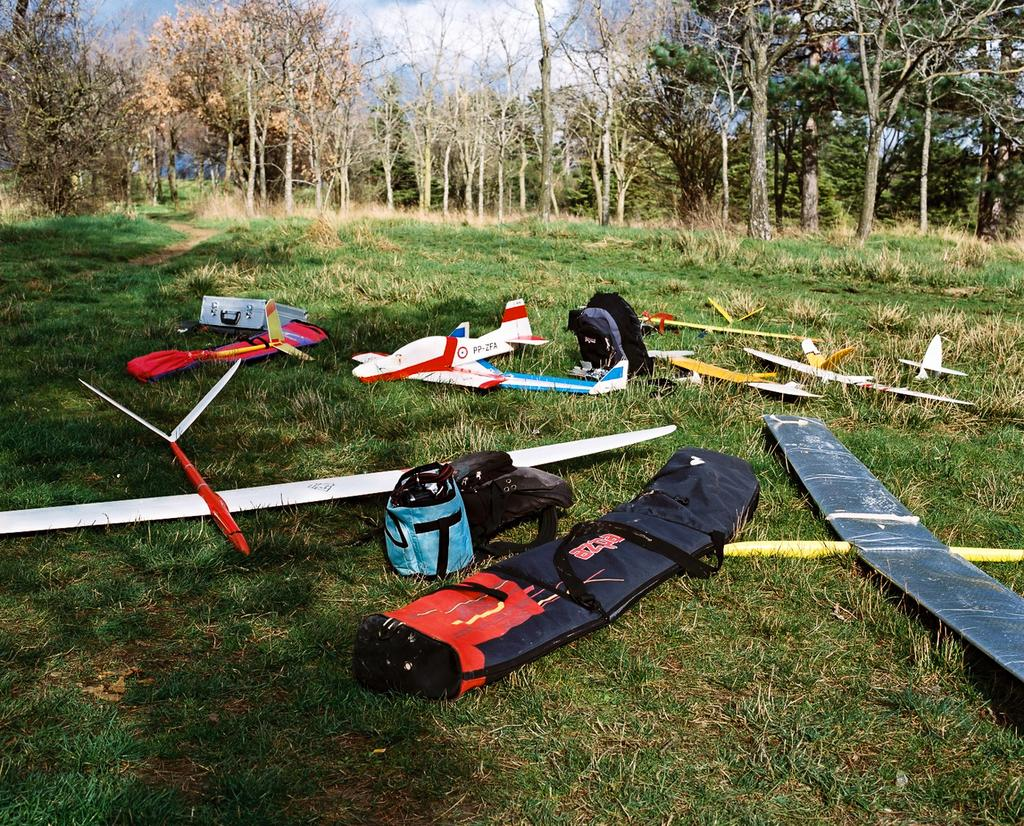What type of toys are present in the image? There are toy aircrafts in the image. Can you describe the colors of the toy aircrafts? The toy aircrafts are in multiple colors. What else can be seen in the image besides the toy aircrafts? There are bags in the image. How many colors are the bags in the image? The bags are in multiple colors. What can be seen in the background of the image? There are trees in the background of the image. What is the color of the trees in the image? The trees are green. What is visible at the top of the image? The sky is visible in the image. What colors are present in the sky in the image? The sky has both white and blue colors. What type of nerve is visible in the image? There is no nerve present in the image. What type of vest is being worn by the trees in the image? The trees in the image are not wearing any vests. 